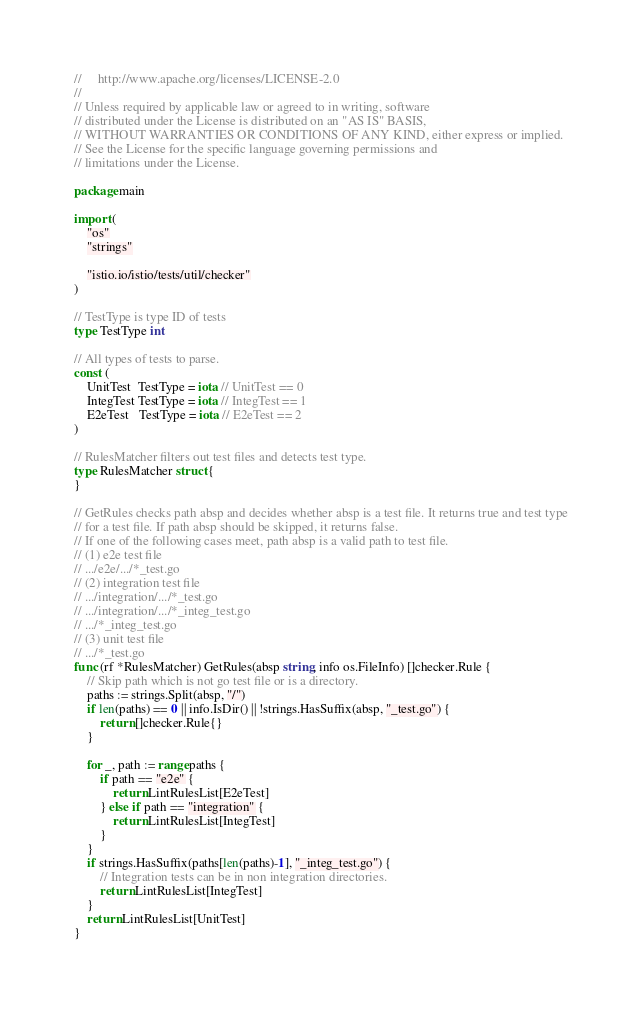<code> <loc_0><loc_0><loc_500><loc_500><_Go_>//     http://www.apache.org/licenses/LICENSE-2.0
//
// Unless required by applicable law or agreed to in writing, software
// distributed under the License is distributed on an "AS IS" BASIS,
// WITHOUT WARRANTIES OR CONDITIONS OF ANY KIND, either express or implied.
// See the License for the specific language governing permissions and
// limitations under the License.

package main

import (
	"os"
	"strings"

	"istio.io/istio/tests/util/checker"
)

// TestType is type ID of tests
type TestType int

// All types of tests to parse.
const (
	UnitTest  TestType = iota // UnitTest == 0
	IntegTest TestType = iota // IntegTest == 1
	E2eTest   TestType = iota // E2eTest == 2
)

// RulesMatcher filters out test files and detects test type.
type RulesMatcher struct {
}

// GetRules checks path absp and decides whether absp is a test file. It returns true and test type
// for a test file. If path absp should be skipped, it returns false.
// If one of the following cases meet, path absp is a valid path to test file.
// (1) e2e test file
// .../e2e/.../*_test.go
// (2) integration test file
// .../integration/.../*_test.go
// .../integration/.../*_integ_test.go
// .../*_integ_test.go
// (3) unit test file
// .../*_test.go
func (rf *RulesMatcher) GetRules(absp string, info os.FileInfo) []checker.Rule {
	// Skip path which is not go test file or is a directory.
	paths := strings.Split(absp, "/")
	if len(paths) == 0 || info.IsDir() || !strings.HasSuffix(absp, "_test.go") {
		return []checker.Rule{}
	}

	for _, path := range paths {
		if path == "e2e" {
			return LintRulesList[E2eTest]
		} else if path == "integration" {
			return LintRulesList[IntegTest]
		}
	}
	if strings.HasSuffix(paths[len(paths)-1], "_integ_test.go") {
		// Integration tests can be in non integration directories.
		return LintRulesList[IntegTest]
	}
	return LintRulesList[UnitTest]
}
</code> 